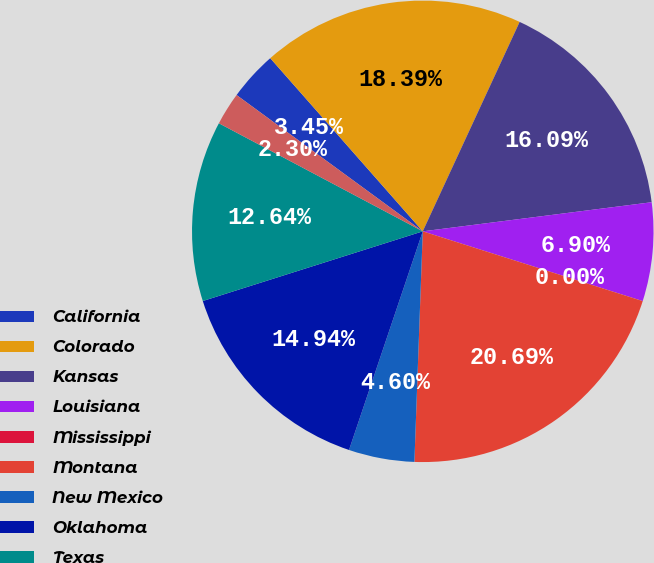Convert chart. <chart><loc_0><loc_0><loc_500><loc_500><pie_chart><fcel>California<fcel>Colorado<fcel>Kansas<fcel>Louisiana<fcel>Mississippi<fcel>Montana<fcel>New Mexico<fcel>Oklahoma<fcel>Texas<fcel>Utah<nl><fcel>3.45%<fcel>18.39%<fcel>16.09%<fcel>6.9%<fcel>0.0%<fcel>20.69%<fcel>4.6%<fcel>14.94%<fcel>12.64%<fcel>2.3%<nl></chart> 